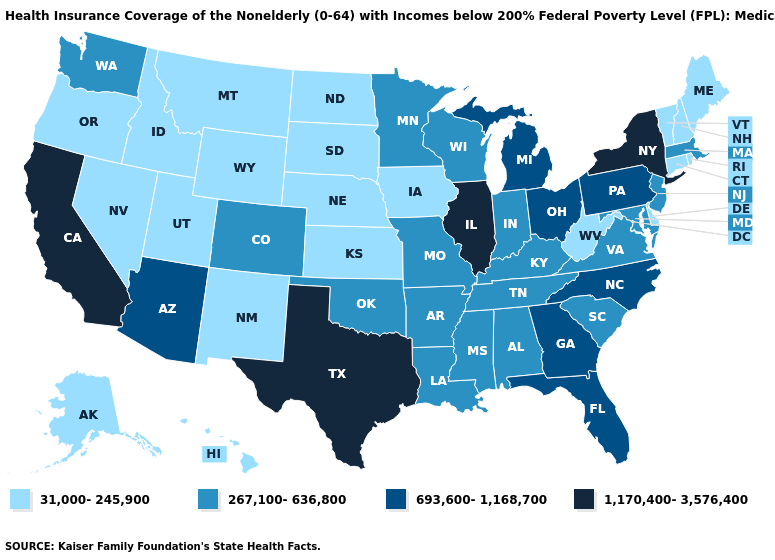What is the value of New York?
Short answer required. 1,170,400-3,576,400. Is the legend a continuous bar?
Write a very short answer. No. What is the value of Connecticut?
Write a very short answer. 31,000-245,900. Does Illinois have the highest value in the USA?
Be succinct. Yes. What is the lowest value in the Northeast?
Answer briefly. 31,000-245,900. What is the value of West Virginia?
Short answer required. 31,000-245,900. Name the states that have a value in the range 1,170,400-3,576,400?
Short answer required. California, Illinois, New York, Texas. Does the map have missing data?
Quick response, please. No. Name the states that have a value in the range 693,600-1,168,700?
Keep it brief. Arizona, Florida, Georgia, Michigan, North Carolina, Ohio, Pennsylvania. Among the states that border Wyoming , which have the highest value?
Give a very brief answer. Colorado. What is the value of Wyoming?
Give a very brief answer. 31,000-245,900. Name the states that have a value in the range 267,100-636,800?
Give a very brief answer. Alabama, Arkansas, Colorado, Indiana, Kentucky, Louisiana, Maryland, Massachusetts, Minnesota, Mississippi, Missouri, New Jersey, Oklahoma, South Carolina, Tennessee, Virginia, Washington, Wisconsin. What is the value of Texas?
Answer briefly. 1,170,400-3,576,400. Among the states that border New York , does New Jersey have the lowest value?
Short answer required. No. Does New Jersey have the lowest value in the Northeast?
Be succinct. No. 